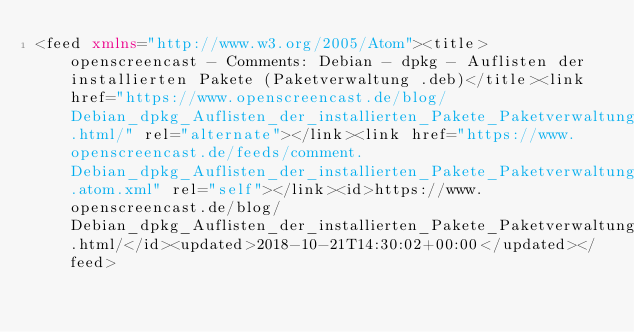<code> <loc_0><loc_0><loc_500><loc_500><_XML_><feed xmlns="http://www.w3.org/2005/Atom"><title>openscreencast - Comments: Debian - dpkg - Auflisten der installierten Pakete (Paketverwaltung .deb)</title><link href="https://www.openscreencast.de/blog/Debian_dpkg_Auflisten_der_installierten_Pakete_Paketverwaltung_deb.html/" rel="alternate"></link><link href="https://www.openscreencast.de/feeds/comment.Debian_dpkg_Auflisten_der_installierten_Pakete_Paketverwaltung_deb.atom.xml" rel="self"></link><id>https://www.openscreencast.de/blog/Debian_dpkg_Auflisten_der_installierten_Pakete_Paketverwaltung_deb.html/</id><updated>2018-10-21T14:30:02+00:00</updated></feed></code> 